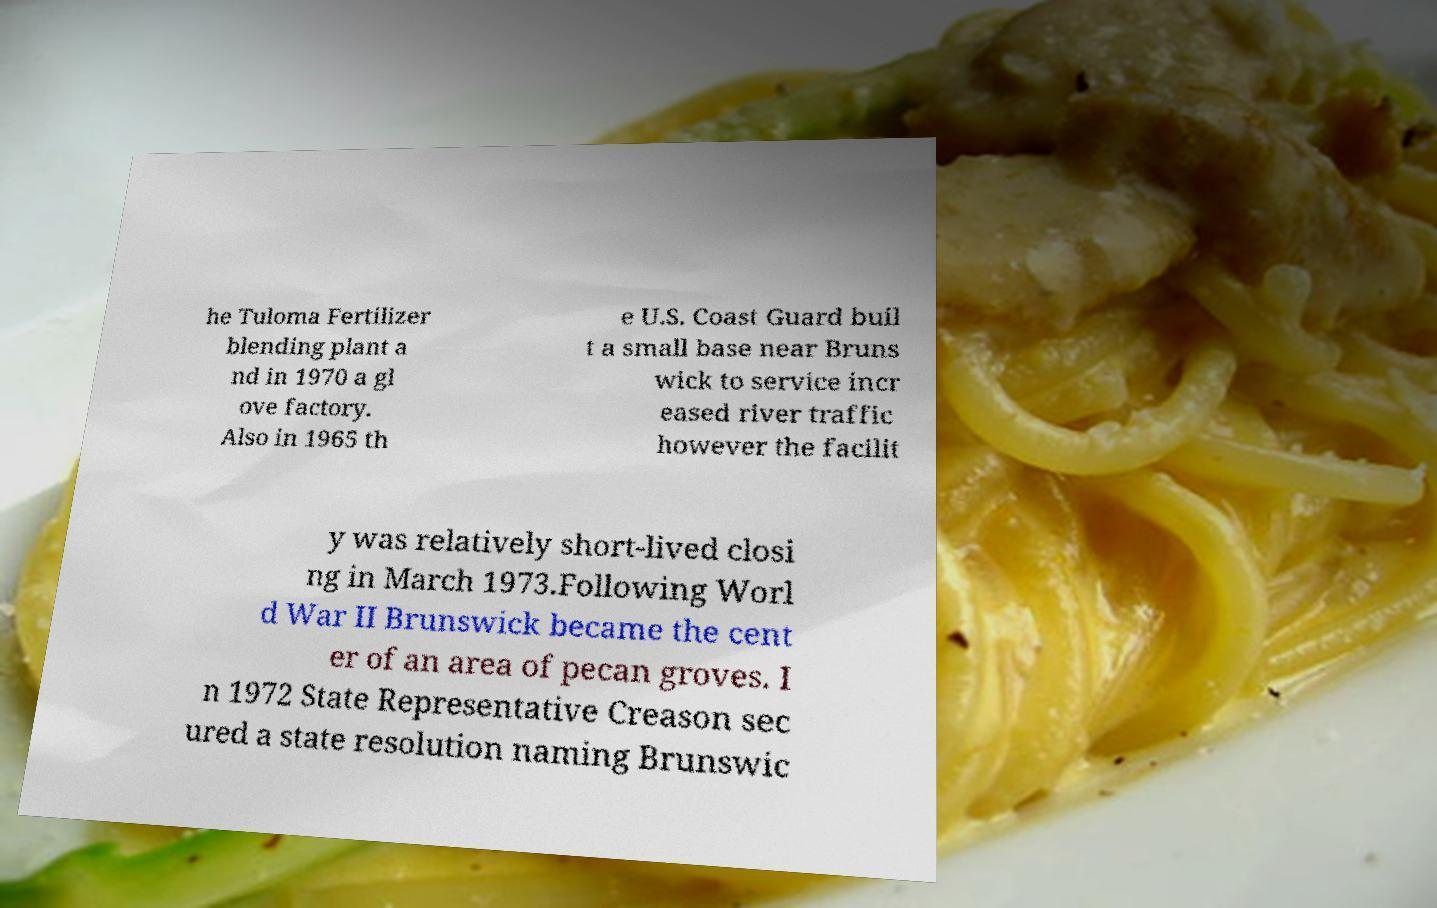Please read and relay the text visible in this image. What does it say? he Tuloma Fertilizer blending plant a nd in 1970 a gl ove factory. Also in 1965 th e U.S. Coast Guard buil t a small base near Bruns wick to service incr eased river traffic however the facilit y was relatively short-lived closi ng in March 1973.Following Worl d War II Brunswick became the cent er of an area of pecan groves. I n 1972 State Representative Creason sec ured a state resolution naming Brunswic 